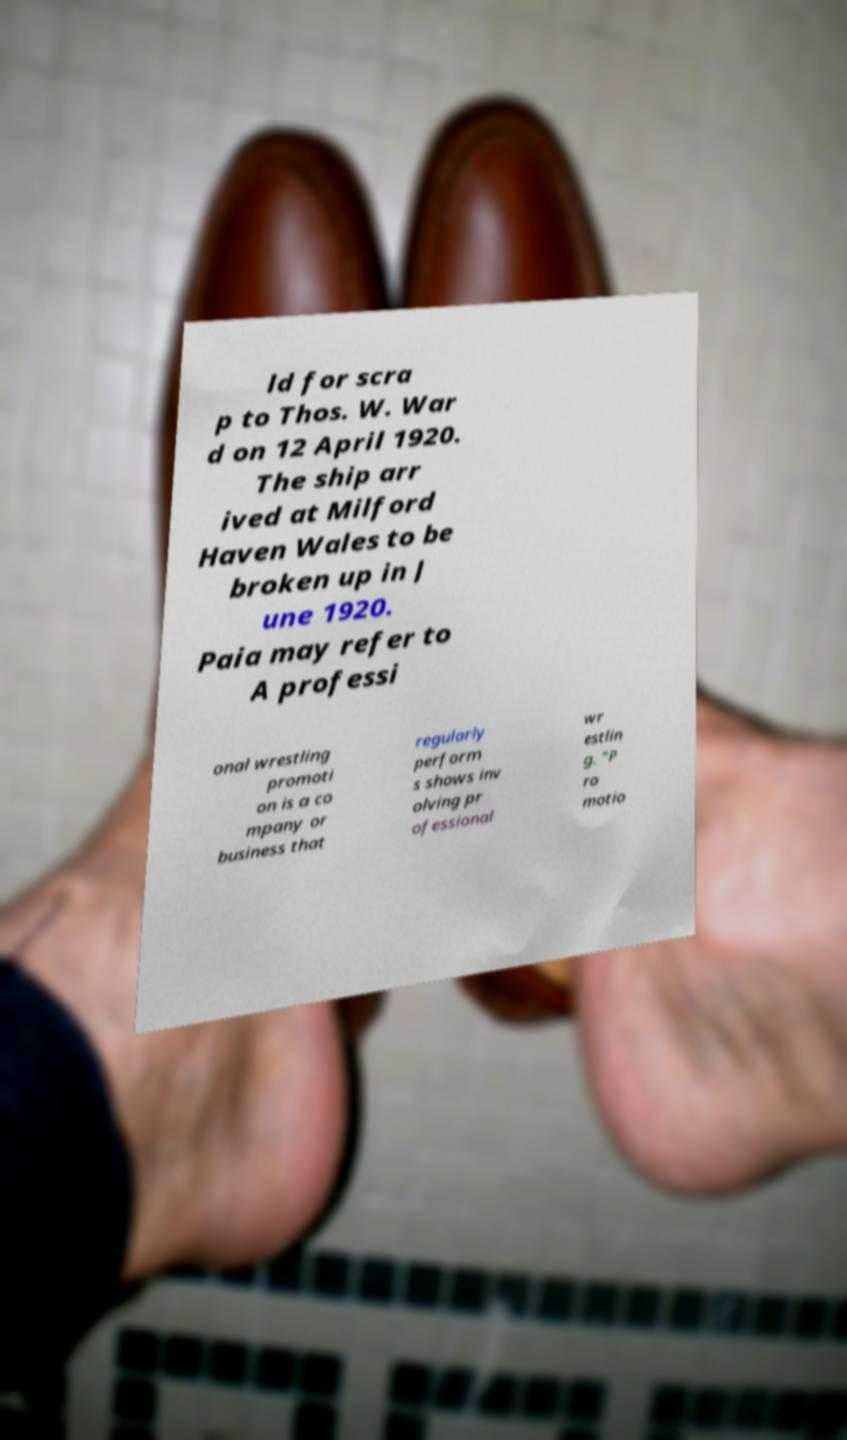For documentation purposes, I need the text within this image transcribed. Could you provide that? ld for scra p to Thos. W. War d on 12 April 1920. The ship arr ived at Milford Haven Wales to be broken up in J une 1920. Paia may refer to A professi onal wrestling promoti on is a co mpany or business that regularly perform s shows inv olving pr ofessional wr estlin g. "P ro motio 